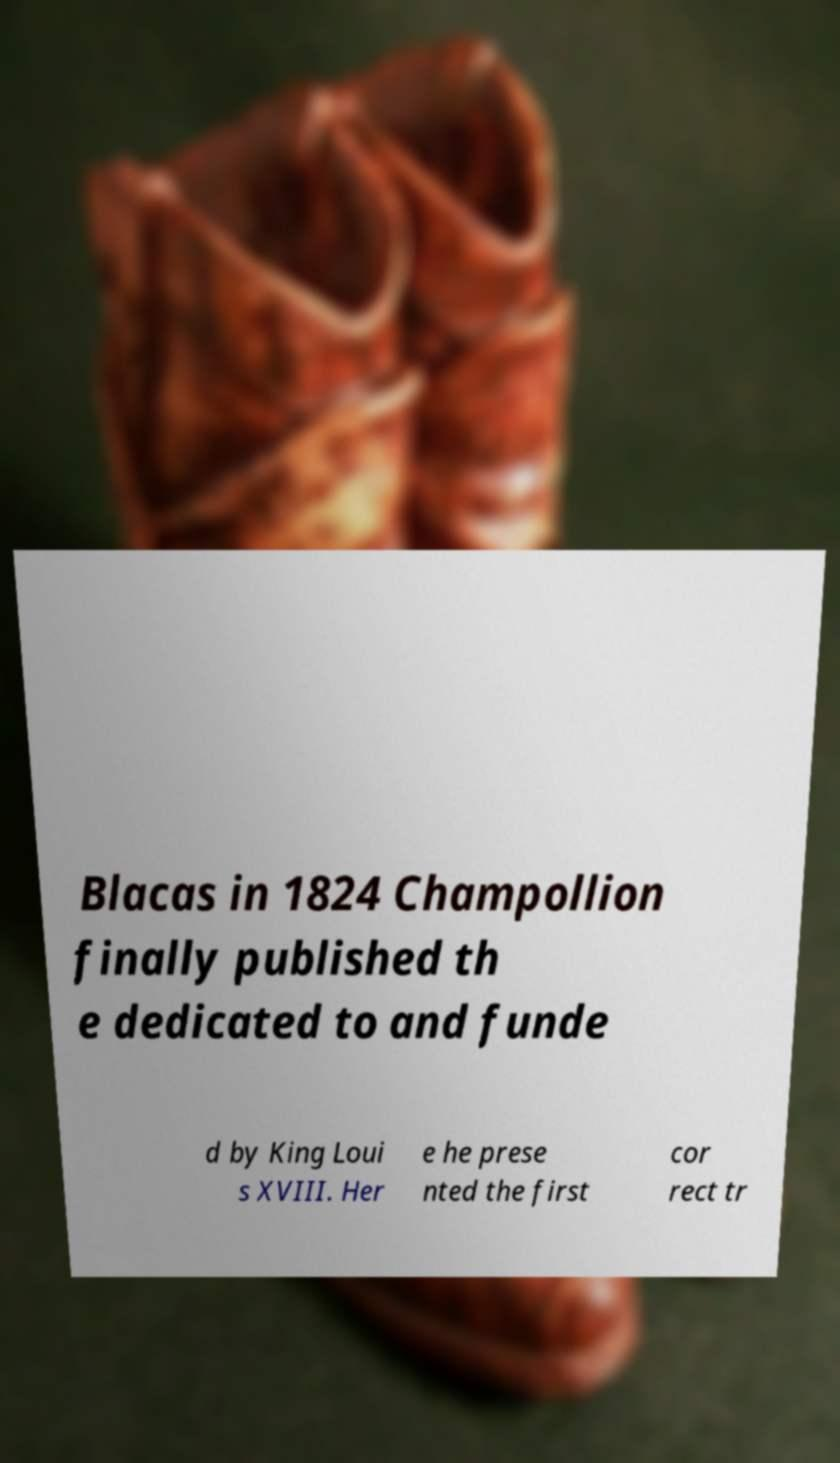Could you assist in decoding the text presented in this image and type it out clearly? Blacas in 1824 Champollion finally published th e dedicated to and funde d by King Loui s XVIII. Her e he prese nted the first cor rect tr 